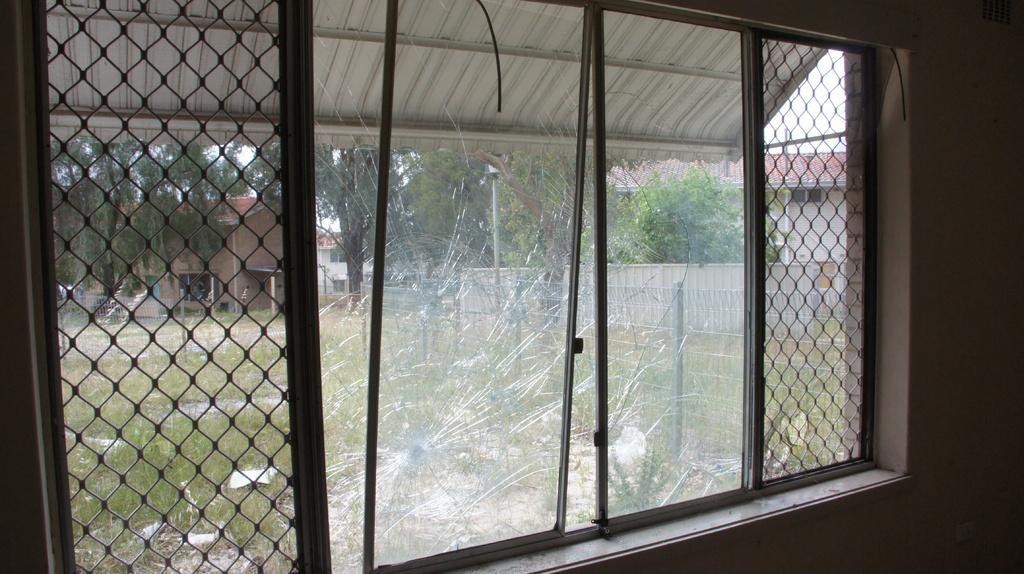How would you summarize this image in a sentence or two? This picture is an inside view of a room. In this picture we can see a window, glass, grilles, wall. Through window we can see the buildings, trees, poles, grass, fencing, wall and sky. 